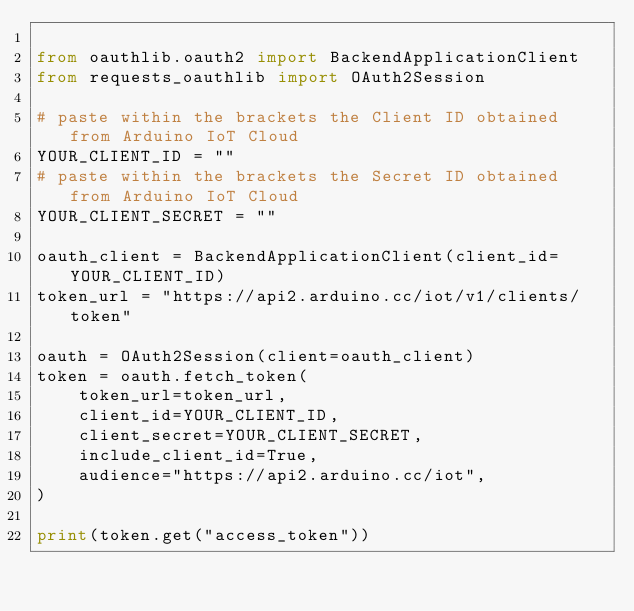Convert code to text. <code><loc_0><loc_0><loc_500><loc_500><_Python_>
from oauthlib.oauth2 import BackendApplicationClient
from requests_oauthlib import OAuth2Session

# paste within the brackets the Client ID obtained from Arduino IoT Cloud 
YOUR_CLIENT_ID = "" 
# paste within the brackets the Secret ID obtained from Arduino IoT Cloud 
YOUR_CLIENT_SECRET = ""

oauth_client = BackendApplicationClient(client_id=YOUR_CLIENT_ID)
token_url = "https://api2.arduino.cc/iot/v1/clients/token"

oauth = OAuth2Session(client=oauth_client)
token = oauth.fetch_token(
    token_url=token_url,
    client_id=YOUR_CLIENT_ID,
    client_secret=YOUR_CLIENT_SECRET,
    include_client_id=True,
    audience="https://api2.arduino.cc/iot",
)

print(token.get("access_token"))</code> 